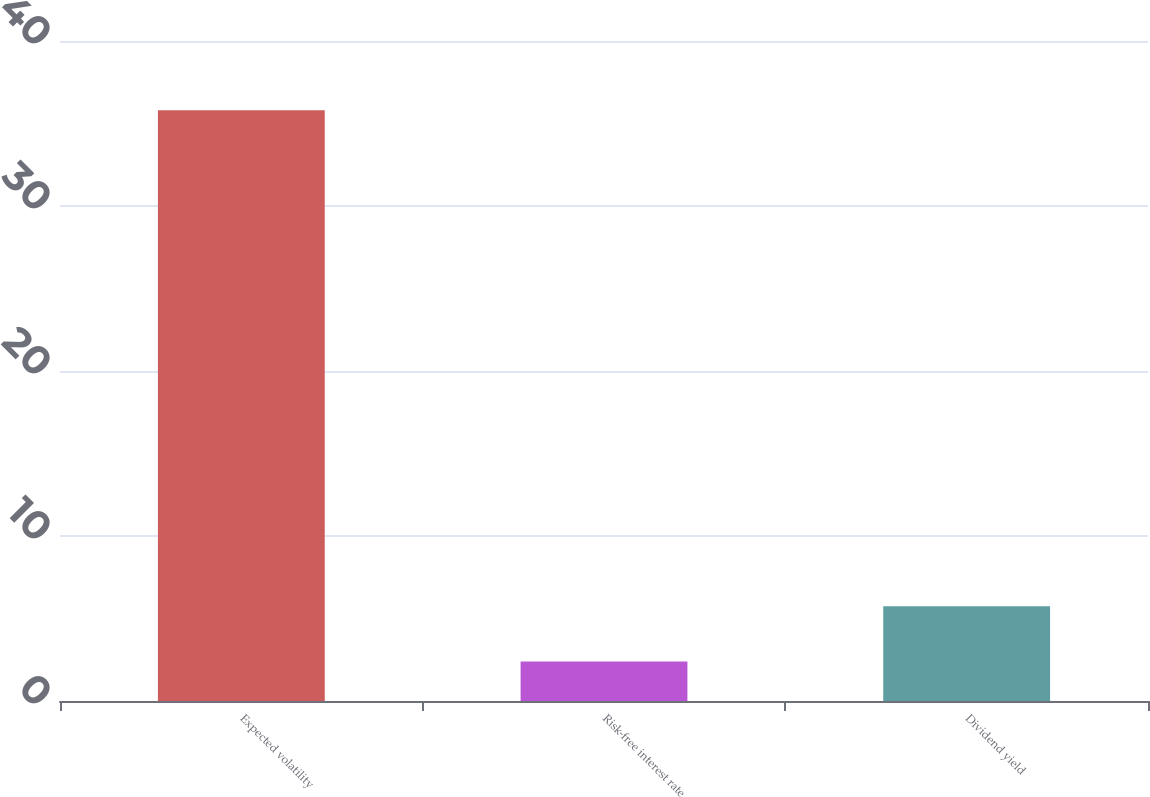Convert chart to OTSL. <chart><loc_0><loc_0><loc_500><loc_500><bar_chart><fcel>Expected volatility<fcel>Risk-free interest rate<fcel>Dividend yield<nl><fcel>35.8<fcel>2.4<fcel>5.74<nl></chart> 